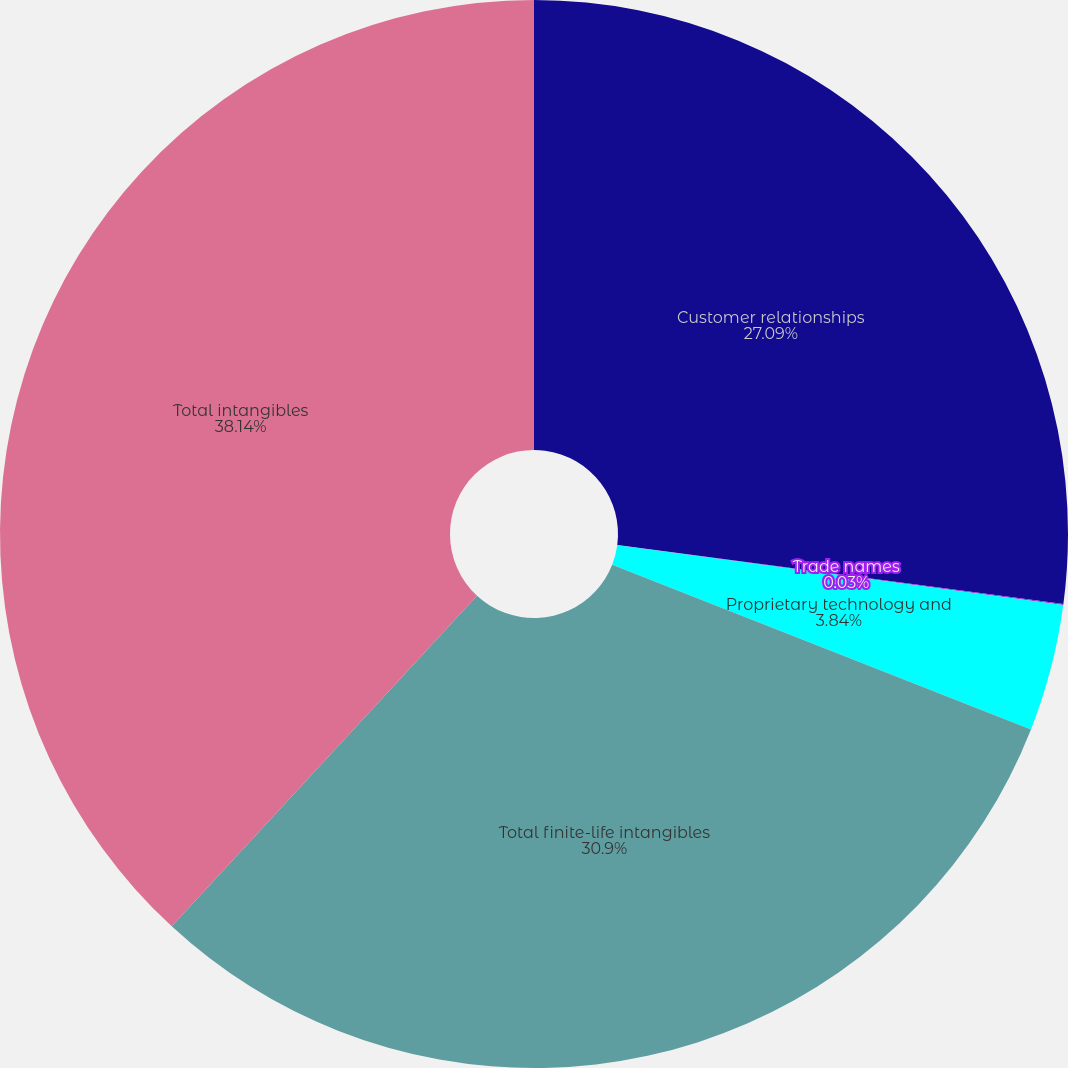<chart> <loc_0><loc_0><loc_500><loc_500><pie_chart><fcel>Customer relationships<fcel>Trade names<fcel>Proprietary technology and<fcel>Total finite-life intangibles<fcel>Total intangibles<nl><fcel>27.09%<fcel>0.03%<fcel>3.84%<fcel>30.9%<fcel>38.13%<nl></chart> 